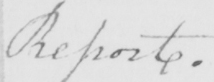Can you read and transcribe this handwriting? Report . 